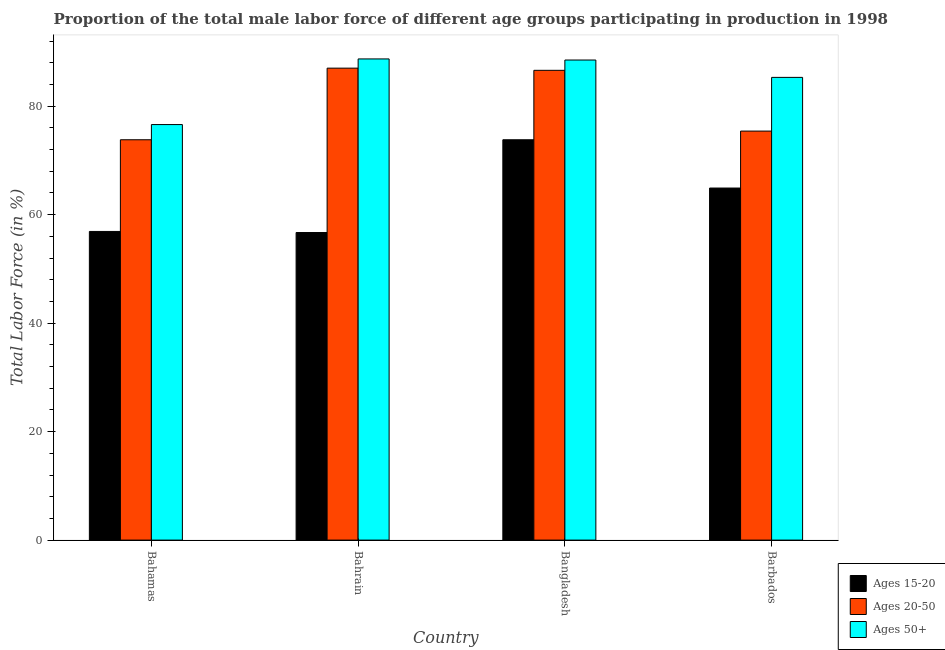How many groups of bars are there?
Offer a very short reply. 4. Are the number of bars on each tick of the X-axis equal?
Keep it short and to the point. Yes. How many bars are there on the 3rd tick from the left?
Your answer should be compact. 3. What is the label of the 1st group of bars from the left?
Your response must be concise. Bahamas. What is the percentage of male labor force within the age group 20-50 in Bangladesh?
Offer a very short reply. 86.6. Across all countries, what is the maximum percentage of male labor force above age 50?
Your response must be concise. 88.7. Across all countries, what is the minimum percentage of male labor force within the age group 20-50?
Ensure brevity in your answer.  73.8. In which country was the percentage of male labor force above age 50 maximum?
Provide a short and direct response. Bahrain. In which country was the percentage of male labor force above age 50 minimum?
Offer a terse response. Bahamas. What is the total percentage of male labor force above age 50 in the graph?
Provide a succinct answer. 339.1. What is the difference between the percentage of male labor force within the age group 15-20 in Bahamas and that in Bangladesh?
Provide a succinct answer. -16.9. What is the difference between the percentage of male labor force above age 50 in Bangladesh and the percentage of male labor force within the age group 15-20 in Bahrain?
Your answer should be very brief. 31.8. What is the average percentage of male labor force within the age group 20-50 per country?
Your answer should be very brief. 80.7. What is the difference between the percentage of male labor force within the age group 20-50 and percentage of male labor force within the age group 15-20 in Bangladesh?
Ensure brevity in your answer.  12.8. In how many countries, is the percentage of male labor force within the age group 20-50 greater than 88 %?
Offer a very short reply. 0. What is the ratio of the percentage of male labor force within the age group 15-20 in Bahrain to that in Bangladesh?
Your answer should be compact. 0.77. What is the difference between the highest and the second highest percentage of male labor force above age 50?
Keep it short and to the point. 0.2. What is the difference between the highest and the lowest percentage of male labor force within the age group 15-20?
Give a very brief answer. 17.1. In how many countries, is the percentage of male labor force within the age group 15-20 greater than the average percentage of male labor force within the age group 15-20 taken over all countries?
Your answer should be very brief. 2. What does the 3rd bar from the left in Bahrain represents?
Provide a succinct answer. Ages 50+. What does the 1st bar from the right in Bahrain represents?
Give a very brief answer. Ages 50+. How many bars are there?
Make the answer very short. 12. How many countries are there in the graph?
Ensure brevity in your answer.  4. What is the difference between two consecutive major ticks on the Y-axis?
Provide a short and direct response. 20. Are the values on the major ticks of Y-axis written in scientific E-notation?
Provide a short and direct response. No. Does the graph contain grids?
Your response must be concise. No. Where does the legend appear in the graph?
Your response must be concise. Bottom right. How many legend labels are there?
Ensure brevity in your answer.  3. How are the legend labels stacked?
Your answer should be very brief. Vertical. What is the title of the graph?
Provide a succinct answer. Proportion of the total male labor force of different age groups participating in production in 1998. Does "Ages 60+" appear as one of the legend labels in the graph?
Your answer should be compact. No. What is the label or title of the Y-axis?
Your answer should be very brief. Total Labor Force (in %). What is the Total Labor Force (in %) in Ages 15-20 in Bahamas?
Your answer should be compact. 56.9. What is the Total Labor Force (in %) of Ages 20-50 in Bahamas?
Your answer should be very brief. 73.8. What is the Total Labor Force (in %) in Ages 50+ in Bahamas?
Give a very brief answer. 76.6. What is the Total Labor Force (in %) of Ages 15-20 in Bahrain?
Offer a very short reply. 56.7. What is the Total Labor Force (in %) of Ages 20-50 in Bahrain?
Your answer should be very brief. 87. What is the Total Labor Force (in %) in Ages 50+ in Bahrain?
Make the answer very short. 88.7. What is the Total Labor Force (in %) of Ages 15-20 in Bangladesh?
Ensure brevity in your answer.  73.8. What is the Total Labor Force (in %) in Ages 20-50 in Bangladesh?
Your response must be concise. 86.6. What is the Total Labor Force (in %) in Ages 50+ in Bangladesh?
Keep it short and to the point. 88.5. What is the Total Labor Force (in %) of Ages 15-20 in Barbados?
Ensure brevity in your answer.  64.9. What is the Total Labor Force (in %) of Ages 20-50 in Barbados?
Ensure brevity in your answer.  75.4. What is the Total Labor Force (in %) in Ages 50+ in Barbados?
Give a very brief answer. 85.3. Across all countries, what is the maximum Total Labor Force (in %) of Ages 15-20?
Provide a succinct answer. 73.8. Across all countries, what is the maximum Total Labor Force (in %) in Ages 50+?
Your answer should be very brief. 88.7. Across all countries, what is the minimum Total Labor Force (in %) of Ages 15-20?
Offer a terse response. 56.7. Across all countries, what is the minimum Total Labor Force (in %) of Ages 20-50?
Give a very brief answer. 73.8. Across all countries, what is the minimum Total Labor Force (in %) in Ages 50+?
Provide a succinct answer. 76.6. What is the total Total Labor Force (in %) in Ages 15-20 in the graph?
Offer a very short reply. 252.3. What is the total Total Labor Force (in %) of Ages 20-50 in the graph?
Ensure brevity in your answer.  322.8. What is the total Total Labor Force (in %) in Ages 50+ in the graph?
Provide a short and direct response. 339.1. What is the difference between the Total Labor Force (in %) in Ages 15-20 in Bahamas and that in Bahrain?
Keep it short and to the point. 0.2. What is the difference between the Total Labor Force (in %) in Ages 20-50 in Bahamas and that in Bahrain?
Ensure brevity in your answer.  -13.2. What is the difference between the Total Labor Force (in %) in Ages 50+ in Bahamas and that in Bahrain?
Your answer should be very brief. -12.1. What is the difference between the Total Labor Force (in %) of Ages 15-20 in Bahamas and that in Bangladesh?
Offer a terse response. -16.9. What is the difference between the Total Labor Force (in %) in Ages 15-20 in Bahamas and that in Barbados?
Keep it short and to the point. -8. What is the difference between the Total Labor Force (in %) of Ages 20-50 in Bahamas and that in Barbados?
Your answer should be compact. -1.6. What is the difference between the Total Labor Force (in %) of Ages 50+ in Bahamas and that in Barbados?
Provide a short and direct response. -8.7. What is the difference between the Total Labor Force (in %) of Ages 15-20 in Bahrain and that in Bangladesh?
Make the answer very short. -17.1. What is the difference between the Total Labor Force (in %) of Ages 15-20 in Bahrain and that in Barbados?
Your response must be concise. -8.2. What is the difference between the Total Labor Force (in %) in Ages 15-20 in Bahamas and the Total Labor Force (in %) in Ages 20-50 in Bahrain?
Provide a short and direct response. -30.1. What is the difference between the Total Labor Force (in %) of Ages 15-20 in Bahamas and the Total Labor Force (in %) of Ages 50+ in Bahrain?
Keep it short and to the point. -31.8. What is the difference between the Total Labor Force (in %) in Ages 20-50 in Bahamas and the Total Labor Force (in %) in Ages 50+ in Bahrain?
Offer a very short reply. -14.9. What is the difference between the Total Labor Force (in %) in Ages 15-20 in Bahamas and the Total Labor Force (in %) in Ages 20-50 in Bangladesh?
Keep it short and to the point. -29.7. What is the difference between the Total Labor Force (in %) of Ages 15-20 in Bahamas and the Total Labor Force (in %) of Ages 50+ in Bangladesh?
Give a very brief answer. -31.6. What is the difference between the Total Labor Force (in %) of Ages 20-50 in Bahamas and the Total Labor Force (in %) of Ages 50+ in Bangladesh?
Your answer should be very brief. -14.7. What is the difference between the Total Labor Force (in %) in Ages 15-20 in Bahamas and the Total Labor Force (in %) in Ages 20-50 in Barbados?
Give a very brief answer. -18.5. What is the difference between the Total Labor Force (in %) in Ages 15-20 in Bahamas and the Total Labor Force (in %) in Ages 50+ in Barbados?
Keep it short and to the point. -28.4. What is the difference between the Total Labor Force (in %) in Ages 20-50 in Bahamas and the Total Labor Force (in %) in Ages 50+ in Barbados?
Provide a short and direct response. -11.5. What is the difference between the Total Labor Force (in %) in Ages 15-20 in Bahrain and the Total Labor Force (in %) in Ages 20-50 in Bangladesh?
Offer a very short reply. -29.9. What is the difference between the Total Labor Force (in %) of Ages 15-20 in Bahrain and the Total Labor Force (in %) of Ages 50+ in Bangladesh?
Make the answer very short. -31.8. What is the difference between the Total Labor Force (in %) of Ages 20-50 in Bahrain and the Total Labor Force (in %) of Ages 50+ in Bangladesh?
Your answer should be compact. -1.5. What is the difference between the Total Labor Force (in %) of Ages 15-20 in Bahrain and the Total Labor Force (in %) of Ages 20-50 in Barbados?
Make the answer very short. -18.7. What is the difference between the Total Labor Force (in %) in Ages 15-20 in Bahrain and the Total Labor Force (in %) in Ages 50+ in Barbados?
Your answer should be very brief. -28.6. What is the difference between the Total Labor Force (in %) of Ages 20-50 in Bangladesh and the Total Labor Force (in %) of Ages 50+ in Barbados?
Ensure brevity in your answer.  1.3. What is the average Total Labor Force (in %) in Ages 15-20 per country?
Ensure brevity in your answer.  63.08. What is the average Total Labor Force (in %) of Ages 20-50 per country?
Keep it short and to the point. 80.7. What is the average Total Labor Force (in %) of Ages 50+ per country?
Your answer should be compact. 84.78. What is the difference between the Total Labor Force (in %) in Ages 15-20 and Total Labor Force (in %) in Ages 20-50 in Bahamas?
Offer a terse response. -16.9. What is the difference between the Total Labor Force (in %) of Ages 15-20 and Total Labor Force (in %) of Ages 50+ in Bahamas?
Your response must be concise. -19.7. What is the difference between the Total Labor Force (in %) in Ages 15-20 and Total Labor Force (in %) in Ages 20-50 in Bahrain?
Provide a succinct answer. -30.3. What is the difference between the Total Labor Force (in %) of Ages 15-20 and Total Labor Force (in %) of Ages 50+ in Bahrain?
Make the answer very short. -32. What is the difference between the Total Labor Force (in %) in Ages 15-20 and Total Labor Force (in %) in Ages 50+ in Bangladesh?
Keep it short and to the point. -14.7. What is the difference between the Total Labor Force (in %) in Ages 15-20 and Total Labor Force (in %) in Ages 50+ in Barbados?
Provide a short and direct response. -20.4. What is the ratio of the Total Labor Force (in %) of Ages 15-20 in Bahamas to that in Bahrain?
Keep it short and to the point. 1. What is the ratio of the Total Labor Force (in %) of Ages 20-50 in Bahamas to that in Bahrain?
Make the answer very short. 0.85. What is the ratio of the Total Labor Force (in %) in Ages 50+ in Bahamas to that in Bahrain?
Your response must be concise. 0.86. What is the ratio of the Total Labor Force (in %) in Ages 15-20 in Bahamas to that in Bangladesh?
Offer a very short reply. 0.77. What is the ratio of the Total Labor Force (in %) in Ages 20-50 in Bahamas to that in Bangladesh?
Ensure brevity in your answer.  0.85. What is the ratio of the Total Labor Force (in %) of Ages 50+ in Bahamas to that in Bangladesh?
Make the answer very short. 0.87. What is the ratio of the Total Labor Force (in %) of Ages 15-20 in Bahamas to that in Barbados?
Offer a terse response. 0.88. What is the ratio of the Total Labor Force (in %) of Ages 20-50 in Bahamas to that in Barbados?
Your answer should be very brief. 0.98. What is the ratio of the Total Labor Force (in %) of Ages 50+ in Bahamas to that in Barbados?
Provide a succinct answer. 0.9. What is the ratio of the Total Labor Force (in %) in Ages 15-20 in Bahrain to that in Bangladesh?
Ensure brevity in your answer.  0.77. What is the ratio of the Total Labor Force (in %) of Ages 20-50 in Bahrain to that in Bangladesh?
Make the answer very short. 1. What is the ratio of the Total Labor Force (in %) in Ages 15-20 in Bahrain to that in Barbados?
Make the answer very short. 0.87. What is the ratio of the Total Labor Force (in %) in Ages 20-50 in Bahrain to that in Barbados?
Your answer should be compact. 1.15. What is the ratio of the Total Labor Force (in %) in Ages 50+ in Bahrain to that in Barbados?
Your answer should be very brief. 1.04. What is the ratio of the Total Labor Force (in %) of Ages 15-20 in Bangladesh to that in Barbados?
Offer a terse response. 1.14. What is the ratio of the Total Labor Force (in %) in Ages 20-50 in Bangladesh to that in Barbados?
Provide a succinct answer. 1.15. What is the ratio of the Total Labor Force (in %) in Ages 50+ in Bangladesh to that in Barbados?
Offer a terse response. 1.04. What is the difference between the highest and the second highest Total Labor Force (in %) in Ages 15-20?
Your answer should be very brief. 8.9. What is the difference between the highest and the lowest Total Labor Force (in %) of Ages 50+?
Provide a succinct answer. 12.1. 